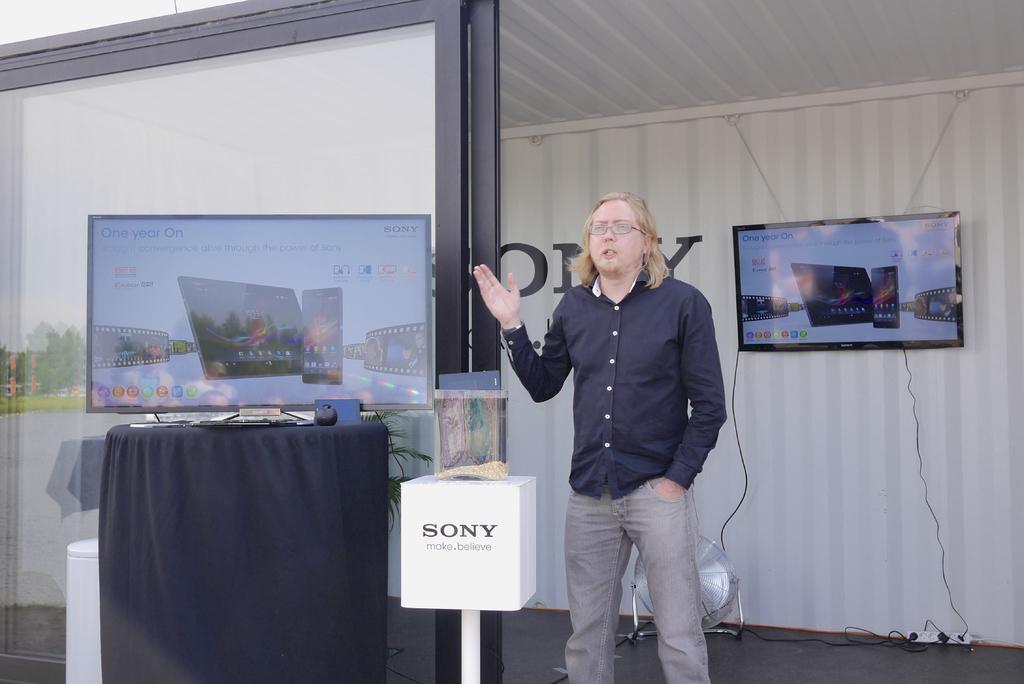What is the tagline below sony?
Your answer should be very brief. Make beleive. 